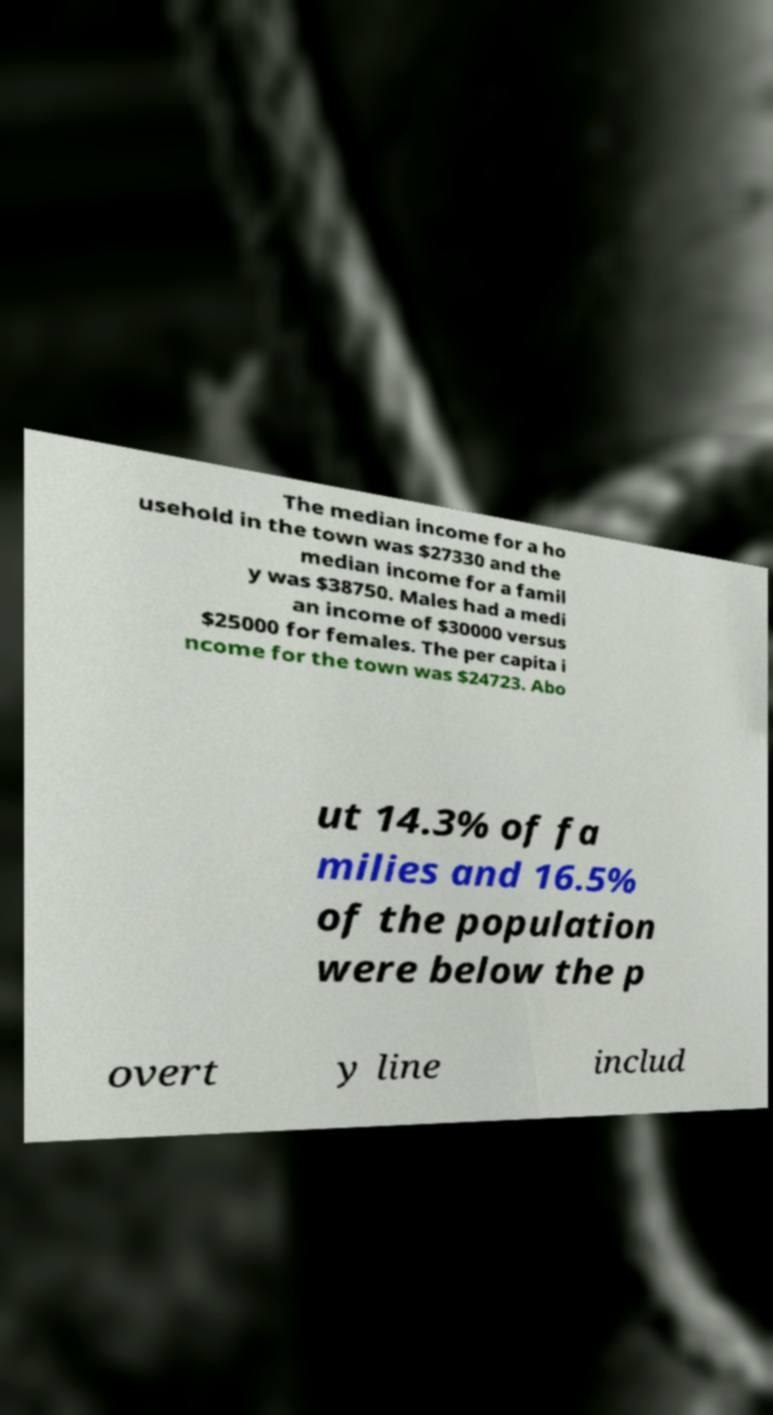Could you extract and type out the text from this image? The median income for a ho usehold in the town was $27330 and the median income for a famil y was $38750. Males had a medi an income of $30000 versus $25000 for females. The per capita i ncome for the town was $24723. Abo ut 14.3% of fa milies and 16.5% of the population were below the p overt y line includ 